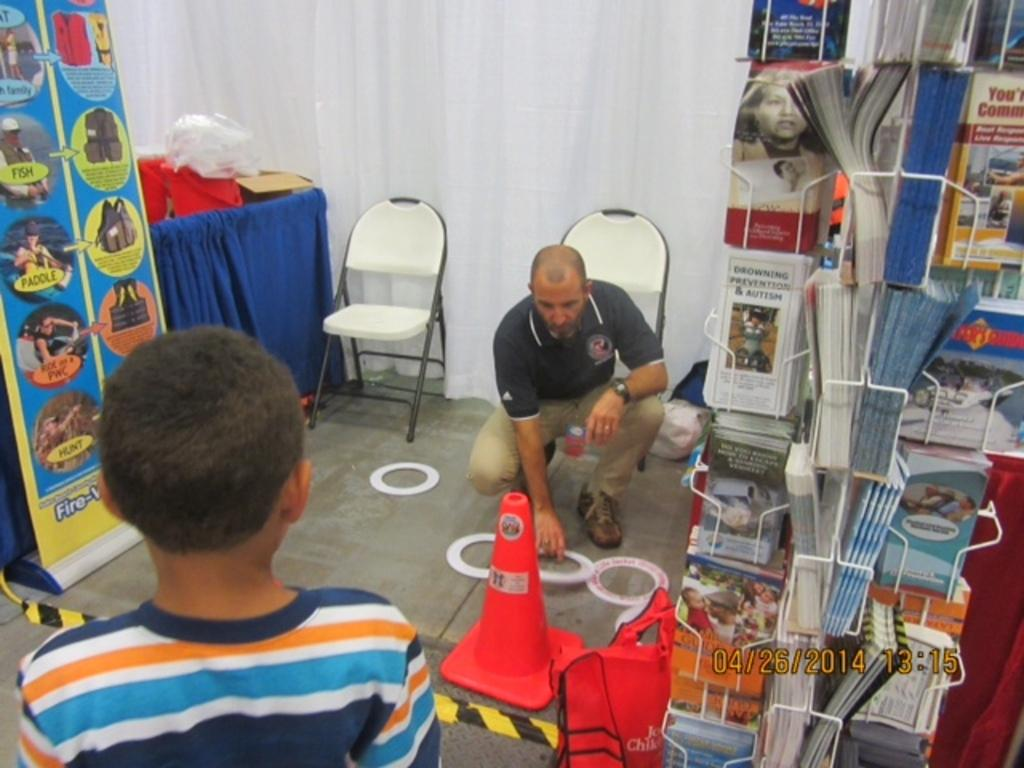How many people are present in the image? There are two persons in the image. What objects can be seen in the image besides the people? There are books and chairs in the image. What color is the curtain visible in the image? There is a blue curtain in the image. What type of island can be seen in the background of the image? There is no island present in the image; it is an indoor setting with a blue curtain. 